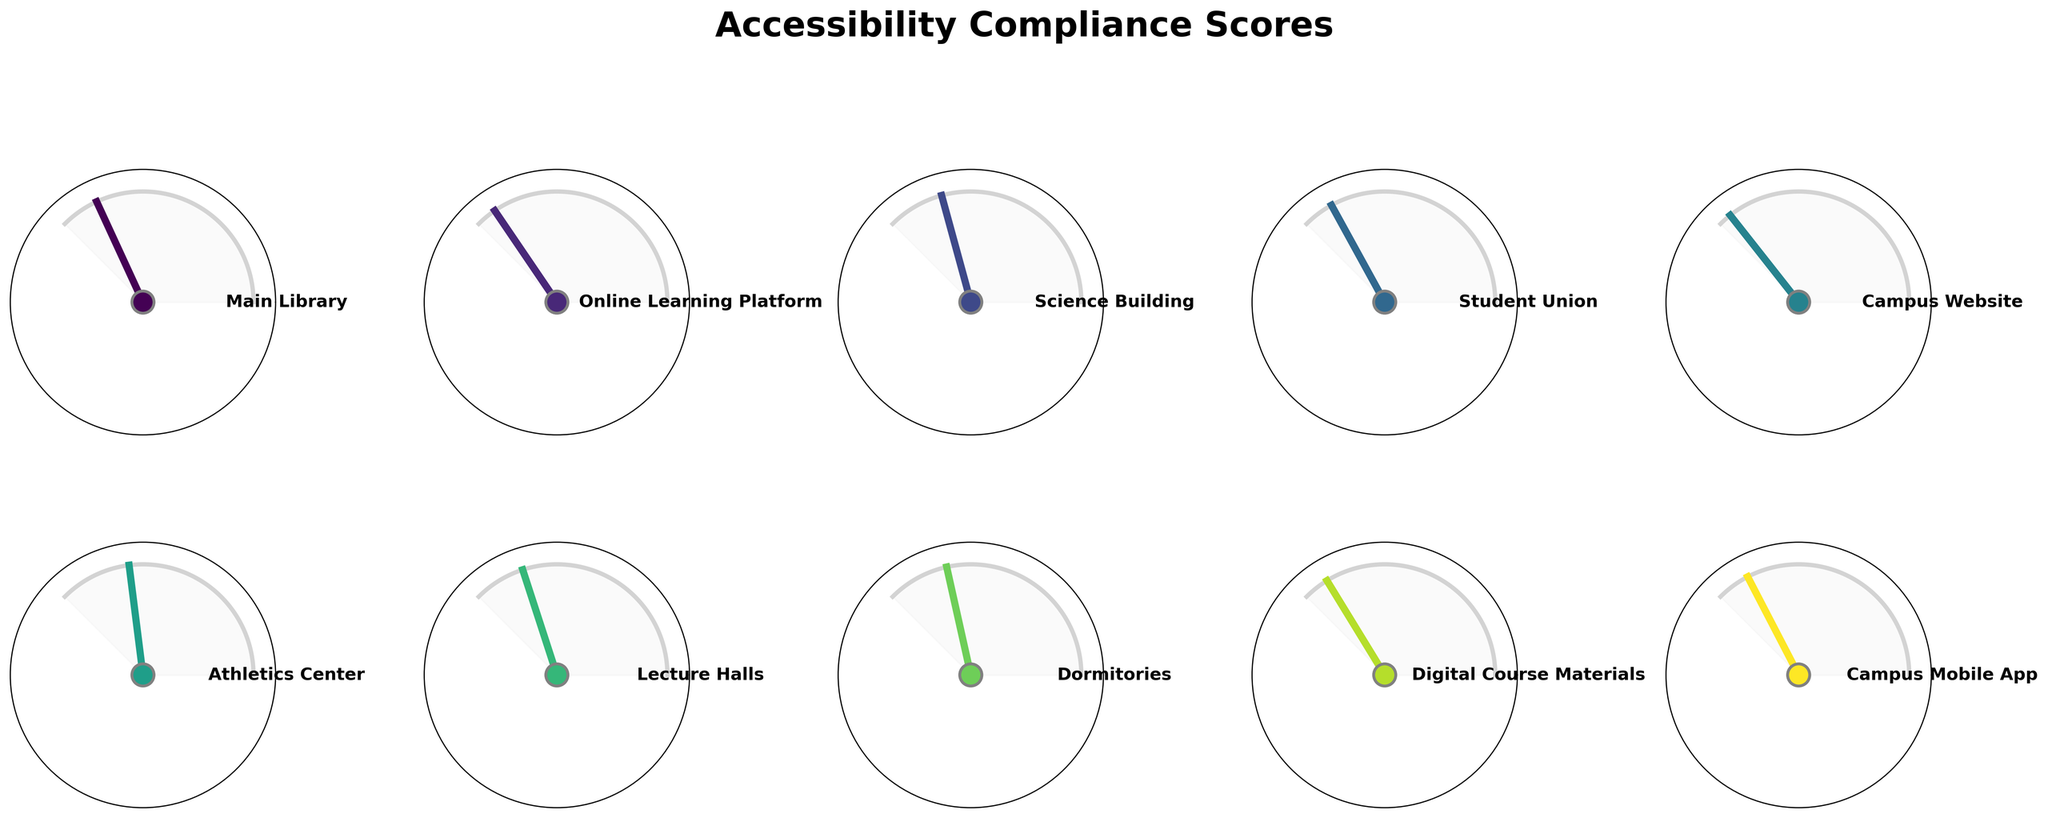What's the title of the figure? The title of the figure is prominently displayed at the top and reads "Accessibility Compliance Scores"
Answer: Accessibility Compliance Scores What is the highest accessibility score and which facility does it correspond to? The highest accessibility score is 95%. By looking at the figure, this score corresponds to the "Campus Website."
Answer: Campus Website How many facilities or resources scored above 90%? To determine this, we identify the gauges that have scores above 90%. The figure shows three facilities or resources: "Online Learning Platform" (92%), "Campus Website" (95%), and "Digital Course Materials" (90%).
Answer: Three What is the average accessibility score of the Science Building and Lecture Halls, rounded to the nearest whole number? The accessibility scores for the Science Building and Lecture Halls are 78% and 80% respectively. The average score is calculated as (78 + 80) / 2 = 79%.
Answer: 79% Which facility has the lowest accessibility score? The lowest accessibility score is 72%. By referring to the figure, this score corresponds to the "Athletics Center."
Answer: Athletics Center Is the Main Library's accessibility score greater than, less than, or equal to the average of all the other facilities/resources? First, calculate the average score of all facilities/resources excluding the Main Library: (92 + 78 + 88 + 95 + 72 + 80 + 76 + 90 + 87) / 9 ≈ 84%. The Main Library's score is 85%, which is greater than 84%.
Answer: Greater than Which facility or resource showed improvement if we assume the previous score was 65% for athletics center? By examining the figure, the Athletics Center has a current score of 72%, indicating an improvement from the previous score of 65%.
Answer: Athletics Center How many facilities or resources have a score between 80% and 90%? Looking at the figure, four facilities or resources have scores in this range: "Main Library" (85%), "Student Union" (88%), "Digital Course Materials" (90%), and "Campus Mobile App" (87%).
Answer: Four 